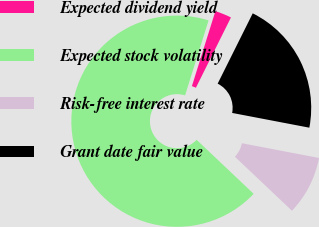Convert chart to OTSL. <chart><loc_0><loc_0><loc_500><loc_500><pie_chart><fcel>Expected dividend yield<fcel>Expected stock volatility<fcel>Risk-free interest rate<fcel>Grant date fair value<nl><fcel>2.53%<fcel>67.77%<fcel>9.06%<fcel>20.64%<nl></chart> 